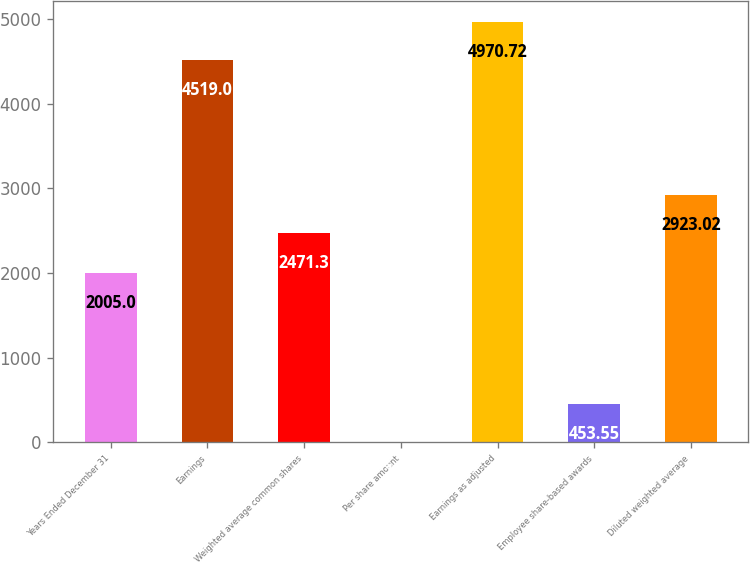Convert chart. <chart><loc_0><loc_0><loc_500><loc_500><bar_chart><fcel>Years Ended December 31<fcel>Earnings<fcel>Weighted average common shares<fcel>Per share amount<fcel>Earnings as adjusted<fcel>Employee share-based awards<fcel>Diluted weighted average<nl><fcel>2005<fcel>4519<fcel>2471.3<fcel>1.83<fcel>4970.72<fcel>453.55<fcel>2923.02<nl></chart> 